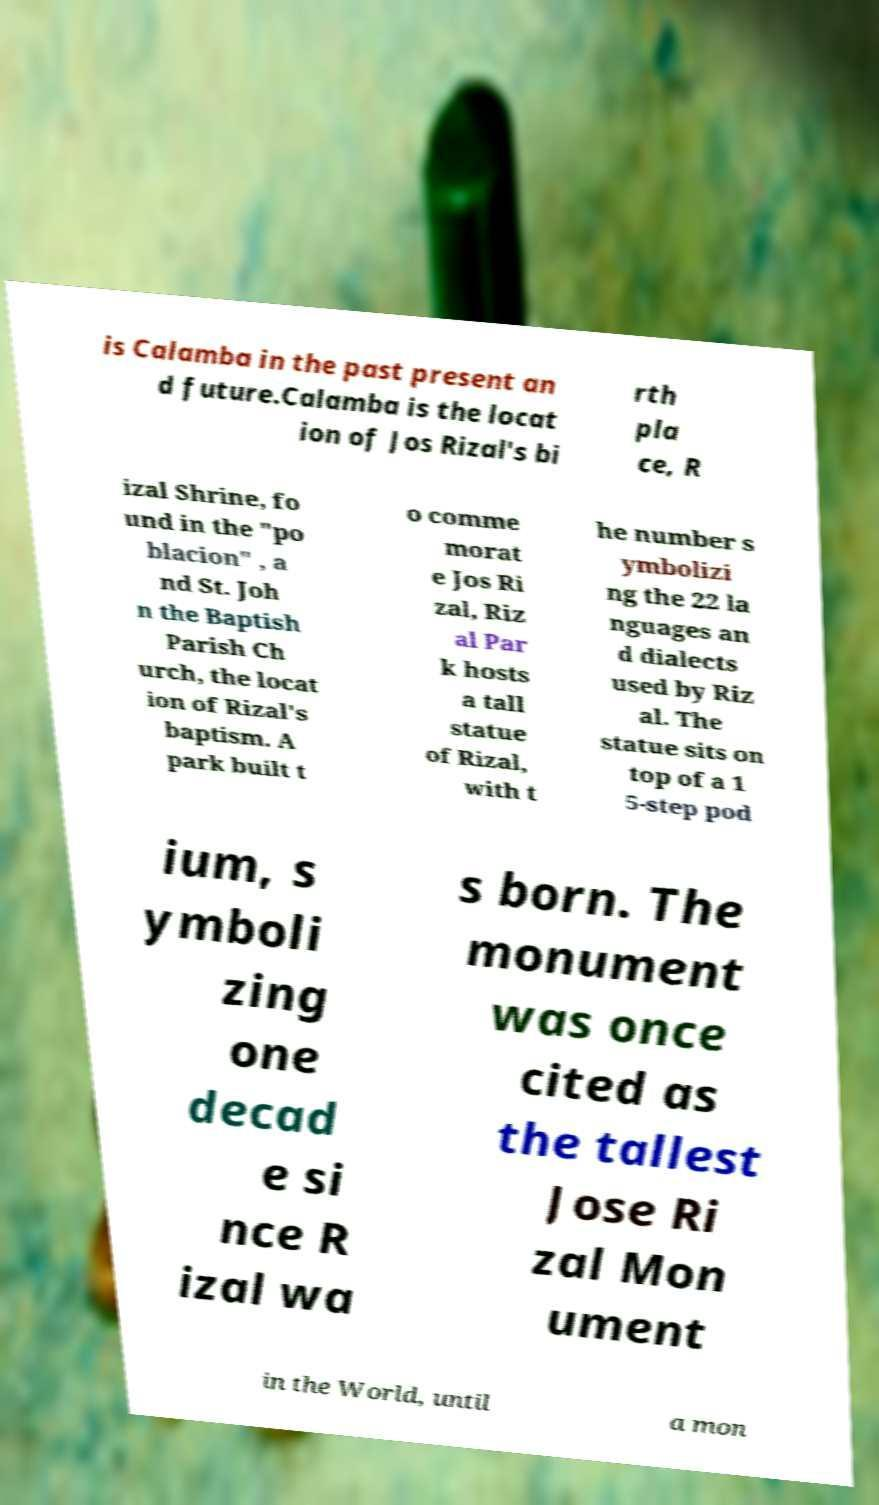I need the written content from this picture converted into text. Can you do that? is Calamba in the past present an d future.Calamba is the locat ion of Jos Rizal's bi rth pla ce, R izal Shrine, fo und in the "po blacion" , a nd St. Joh n the Baptish Parish Ch urch, the locat ion of Rizal's baptism. A park built t o comme morat e Jos Ri zal, Riz al Par k hosts a tall statue of Rizal, with t he number s ymbolizi ng the 22 la nguages an d dialects used by Riz al. The statue sits on top of a 1 5-step pod ium, s ymboli zing one decad e si nce R izal wa s born. The monument was once cited as the tallest Jose Ri zal Mon ument in the World, until a mon 